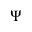<formula> <loc_0><loc_0><loc_500><loc_500>\Psi</formula> 